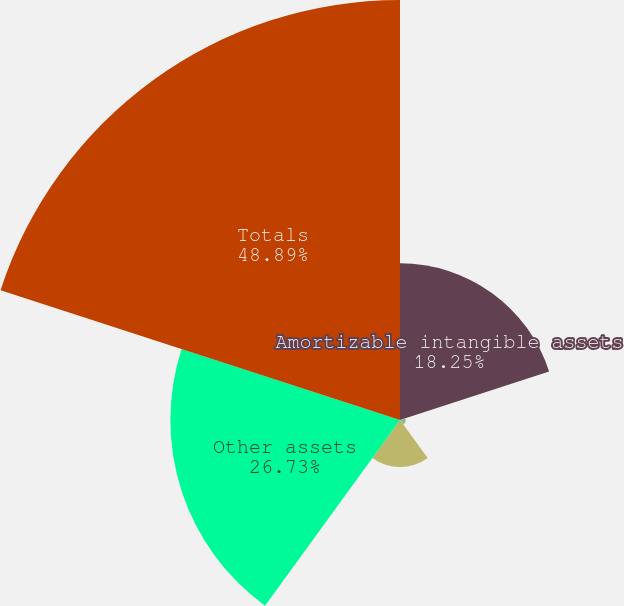<chart> <loc_0><loc_0><loc_500><loc_500><pie_chart><fcel>Amortizable intangible assets<fcel>Indefinite lived intangible<fcel>Fixed assets<fcel>Other assets<fcel>Totals<nl><fcel>18.25%<fcel>0.65%<fcel>5.48%<fcel>26.73%<fcel>48.89%<nl></chart> 